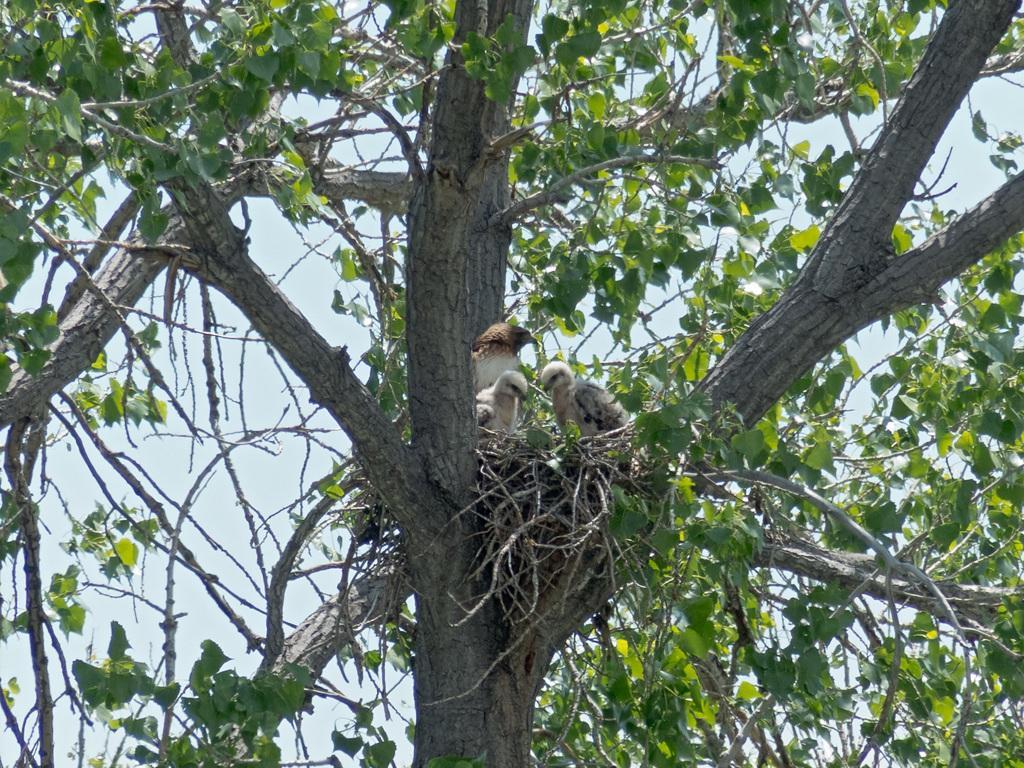Could you give a brief overview of what you see in this image? In this image we can see some birds around the nest which is placed on the branches of a tree. On the backside we can see the sky which looks cloudy. 